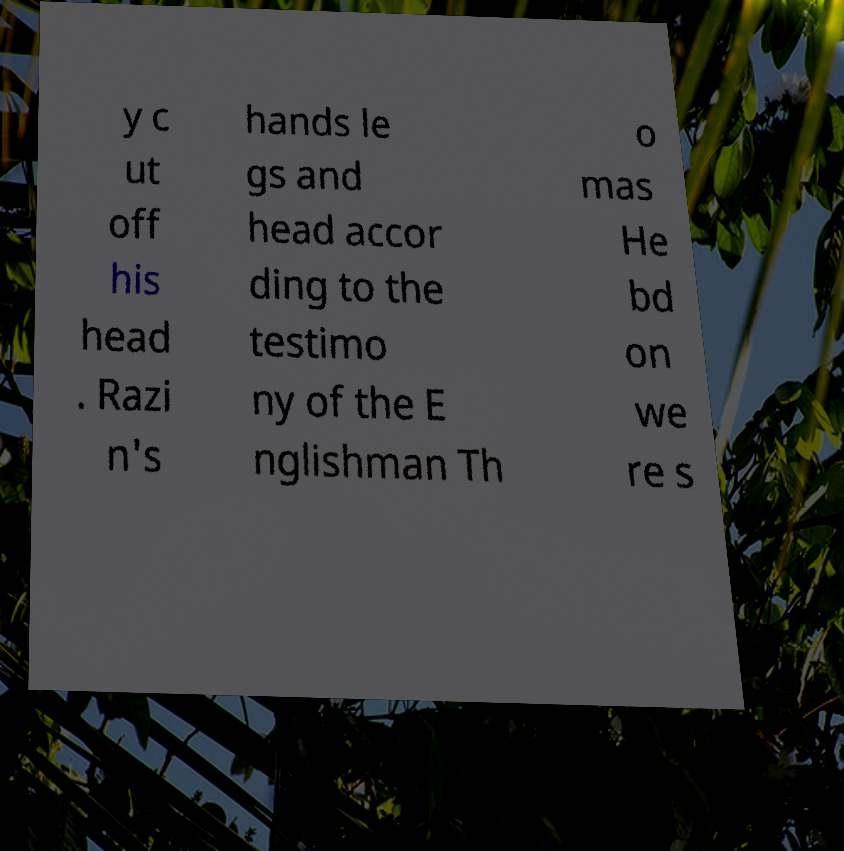What messages or text are displayed in this image? I need them in a readable, typed format. y c ut off his head . Razi n's hands le gs and head accor ding to the testimo ny of the E nglishman Th o mas He bd on we re s 